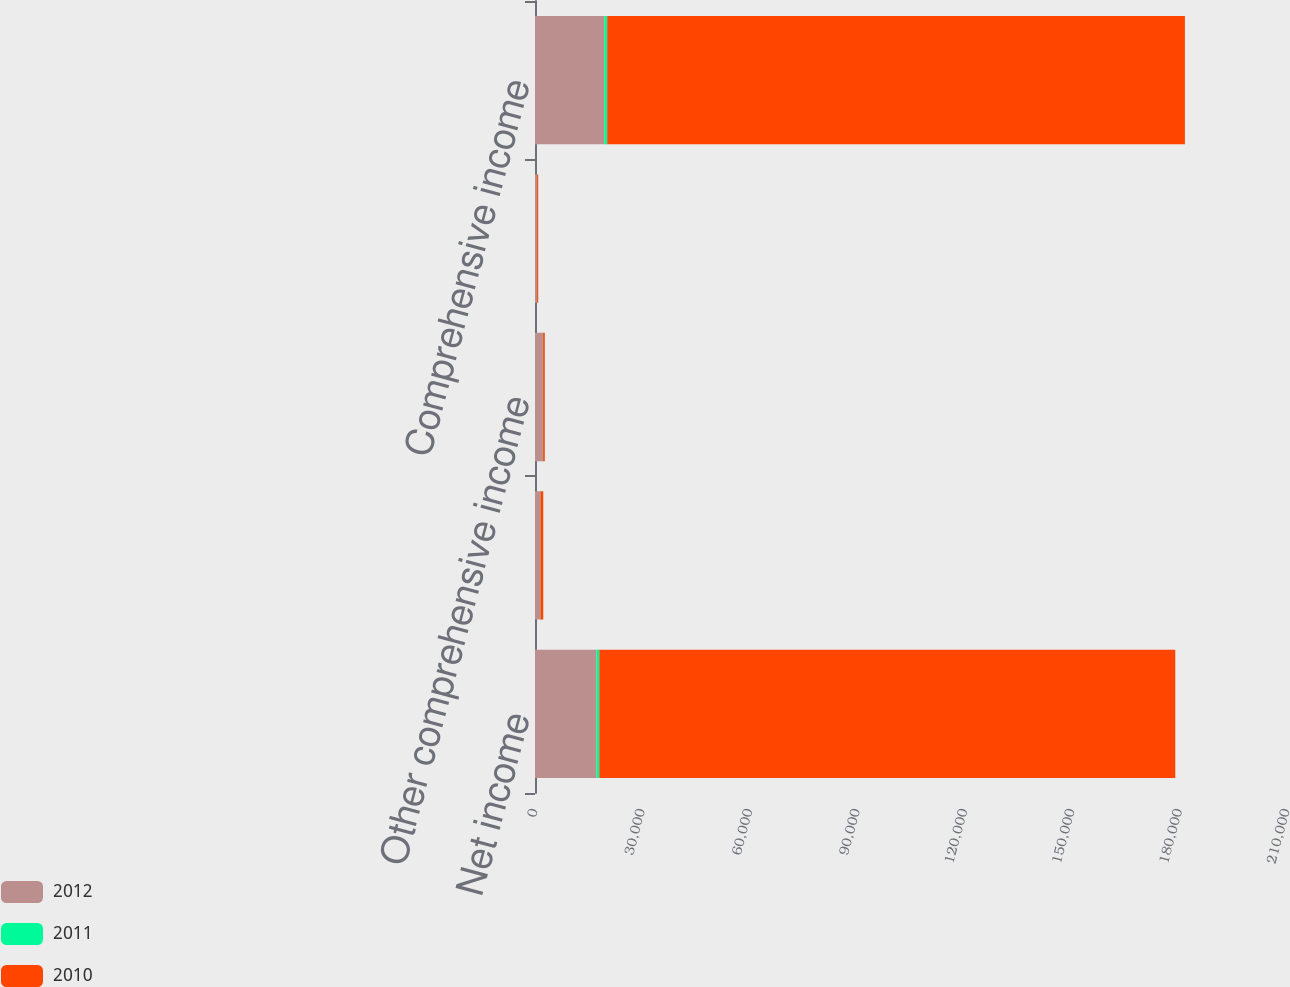<chart> <loc_0><loc_0><loc_500><loc_500><stacked_bar_chart><ecel><fcel>Net income<fcel>Change in unrealized gains on<fcel>Other comprehensive income<fcel>Income tax expense related to<fcel>Comprehensive income<nl><fcel>2012<fcel>17152<fcel>1394<fcel>2213<fcel>538<fcel>19365<nl><fcel>2011<fcel>798<fcel>111<fcel>44<fcel>43<fcel>798<nl><fcel>2010<fcel>160853<fcel>798<fcel>477<fcel>321<fcel>161330<nl></chart> 